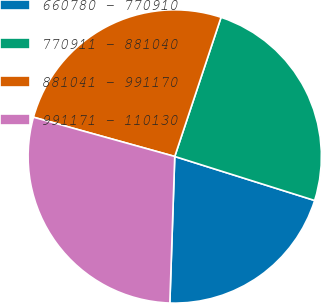Convert chart. <chart><loc_0><loc_0><loc_500><loc_500><pie_chart><fcel>660780 - 770910<fcel>770911 - 881040<fcel>881041 - 991170<fcel>991171 - 110130<nl><fcel>20.68%<fcel>24.74%<fcel>25.8%<fcel>28.78%<nl></chart> 